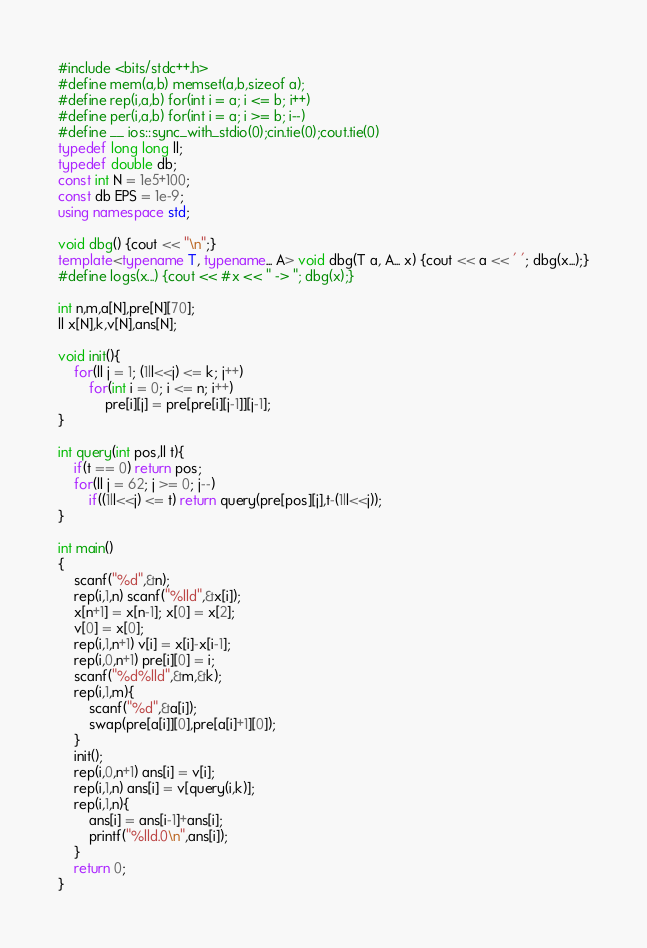Convert code to text. <code><loc_0><loc_0><loc_500><loc_500><_C++_>#include <bits/stdc++.h>
#define mem(a,b) memset(a,b,sizeof a);
#define rep(i,a,b) for(int i = a; i <= b; i++)
#define per(i,a,b) for(int i = a; i >= b; i--)
#define __ ios::sync_with_stdio(0);cin.tie(0);cout.tie(0)
typedef long long ll;
typedef double db;
const int N = 1e5+100;
const db EPS = 1e-9;
using namespace std;

void dbg() {cout << "\n";}
template<typename T, typename... A> void dbg(T a, A... x) {cout << a << ' '; dbg(x...);}
#define logs(x...) {cout << #x << " -> "; dbg(x);}

int n,m,a[N],pre[N][70];
ll x[N],k,v[N],ans[N];

void init(){
	for(ll j = 1; (1ll<<j) <= k; j++)
		for(int i = 0; i <= n; i++)
			pre[i][j] = pre[pre[i][j-1]][j-1];
}

int query(int pos,ll t){
	if(t == 0) return pos;
	for(ll j = 62; j >= 0; j--)
		if((1ll<<j) <= t) return query(pre[pos][j],t-(1ll<<j));
}

int main()
{
	scanf("%d",&n);
	rep(i,1,n) scanf("%lld",&x[i]);
	x[n+1] = x[n-1]; x[0] = x[2];
	v[0] = x[0];
	rep(i,1,n+1) v[i] = x[i]-x[i-1];
	rep(i,0,n+1) pre[i][0] = i;
	scanf("%d%lld",&m,&k);
	rep(i,1,m){
		scanf("%d",&a[i]);
		swap(pre[a[i]][0],pre[a[i]+1][0]);
	}
	init();
	rep(i,0,n+1) ans[i] = v[i];
	rep(i,1,n) ans[i] = v[query(i,k)];
	rep(i,1,n){
		ans[i] = ans[i-1]+ans[i];
		printf("%lld.0\n",ans[i]);
	}
	return 0;
}</code> 